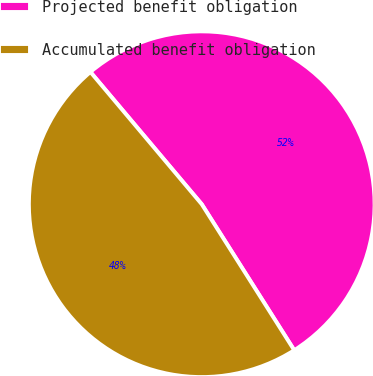Convert chart to OTSL. <chart><loc_0><loc_0><loc_500><loc_500><pie_chart><fcel>Projected benefit obligation<fcel>Accumulated benefit obligation<nl><fcel>52.15%<fcel>47.85%<nl></chart> 